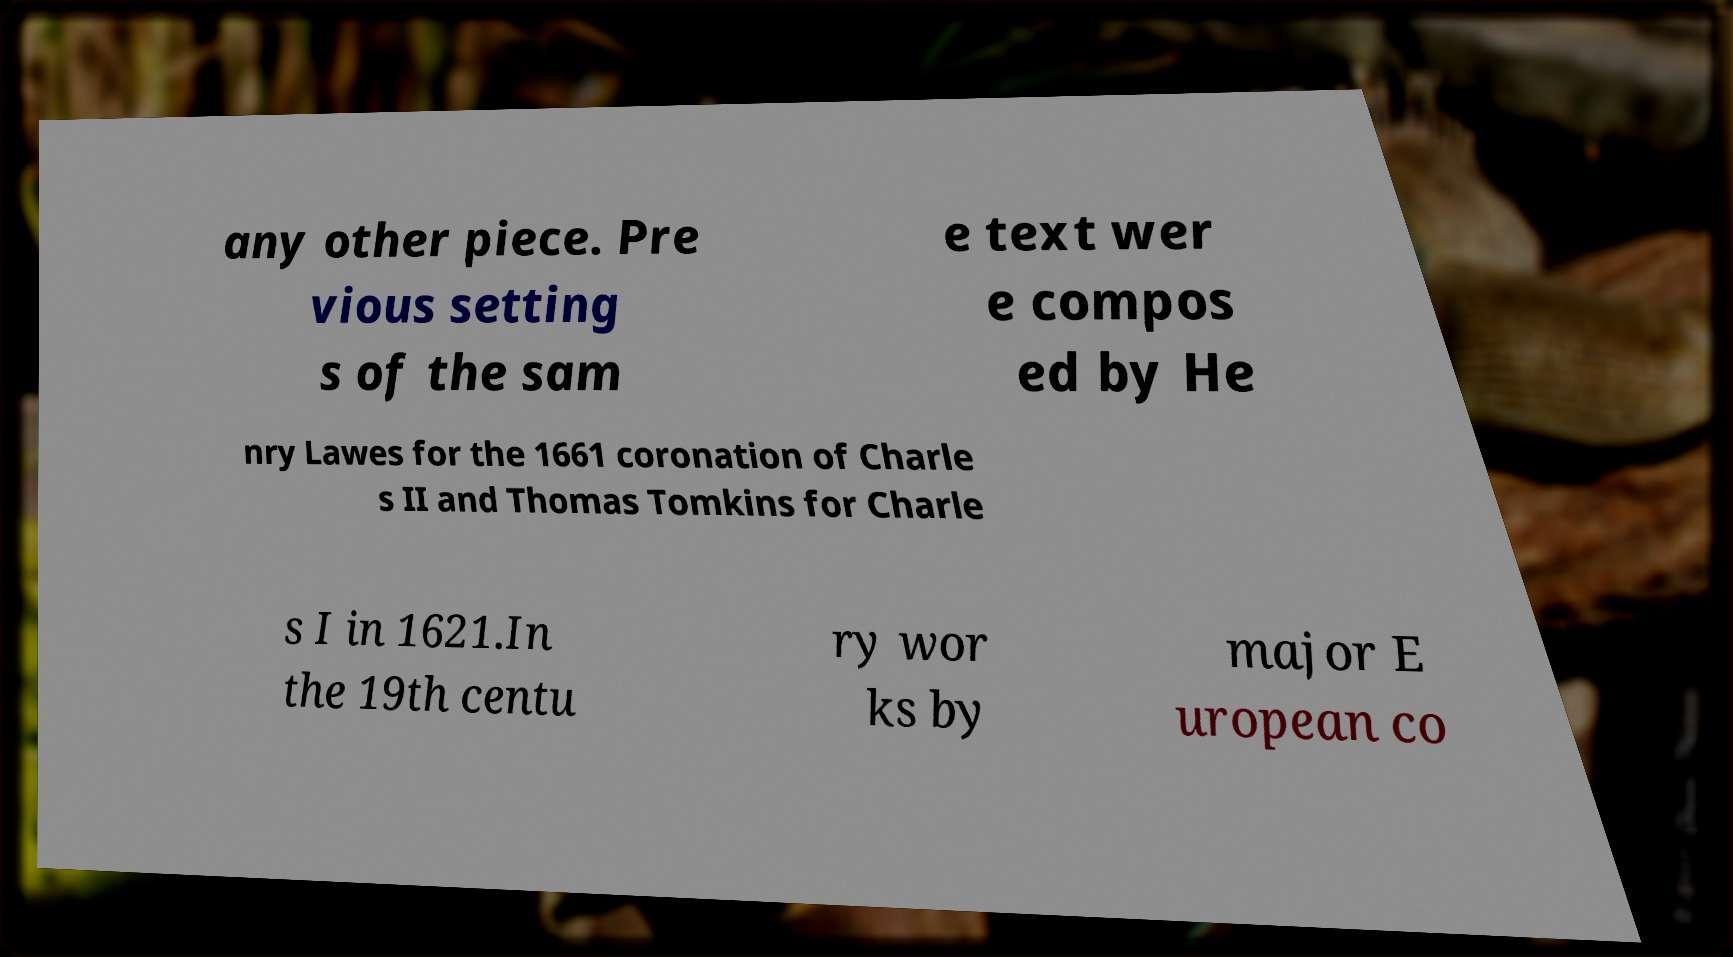Can you read and provide the text displayed in the image?This photo seems to have some interesting text. Can you extract and type it out for me? any other piece. Pre vious setting s of the sam e text wer e compos ed by He nry Lawes for the 1661 coronation of Charle s II and Thomas Tomkins for Charle s I in 1621.In the 19th centu ry wor ks by major E uropean co 